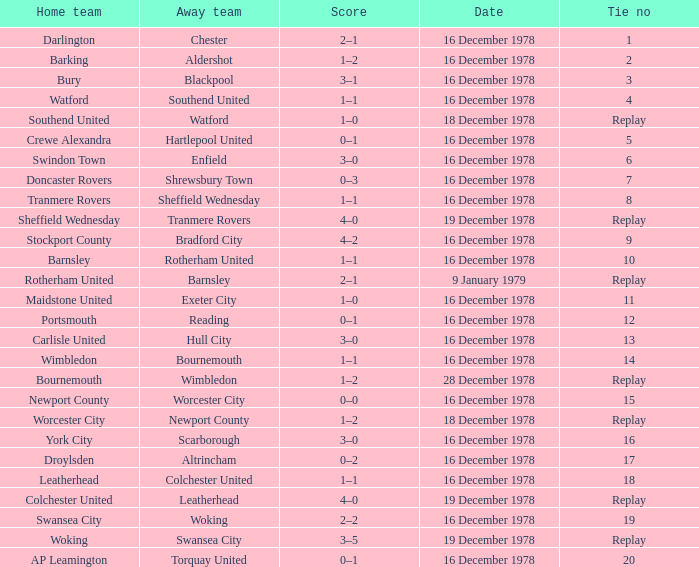What is the tie number for the away team altrincham? 17.0. 